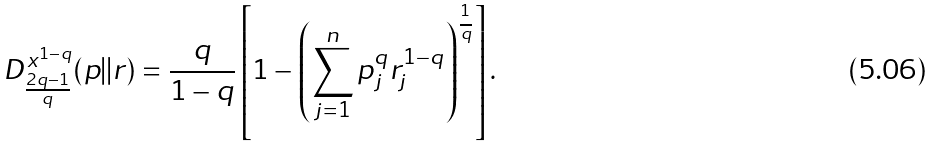<formula> <loc_0><loc_0><loc_500><loc_500>D _ { \frac { 2 q - 1 } { q } } ^ { x ^ { 1 - q } } ( p | | r ) = \frac { q } { 1 - q } \left [ 1 - \left ( \sum _ { j = 1 } ^ { n } p _ { j } ^ { q } r _ { j } ^ { 1 - q } \right ) ^ { \frac { ^ { 1 } } { q } } \right ] .</formula> 